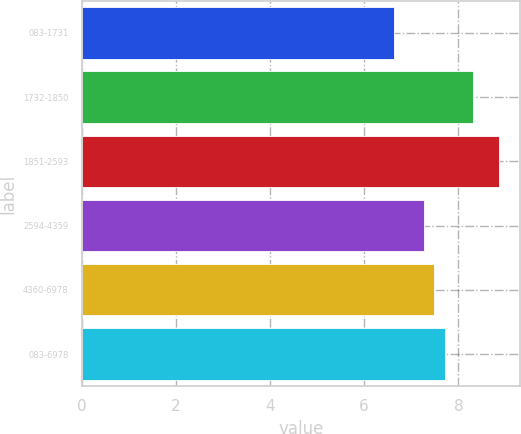Convert chart to OTSL. <chart><loc_0><loc_0><loc_500><loc_500><bar_chart><fcel>083-1731<fcel>1732-1850<fcel>1851-2593<fcel>2594-4359<fcel>4360-6978<fcel>083-6978<nl><fcel>6.63<fcel>8.32<fcel>8.86<fcel>7.27<fcel>7.49<fcel>7.72<nl></chart> 